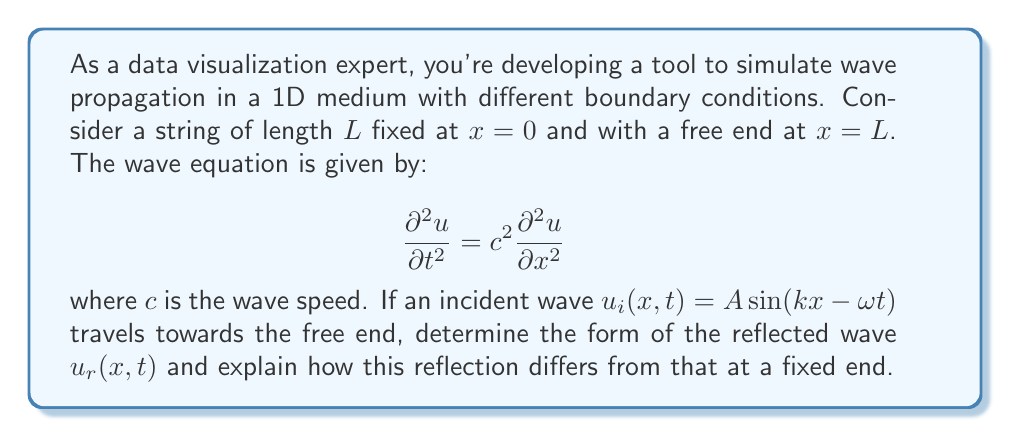Help me with this question. Let's approach this step-by-step:

1) First, recall the boundary conditions:
   - Fixed end at $x=0$: $u(0,t) = 0$
   - Free end at $x=L$: $\frac{\partial u}{\partial x}(L,t) = 0$

2) The incident wave is given by $u_i(x,t) = A \sin(kx - \omega t)$

3) For a free end, the reflected wave will have the same amplitude and phase as the incident wave. This is because the free end allows maximum displacement, resulting in constructive interference.

4) The reflected wave will be traveling in the opposite direction, so we change the sign of $kx$:
   $u_r(x,t) = A \sin(-kx - \omega t)$

5) Using the trigonometric identity $\sin(-\alpha) = -\sin(\alpha)$, we can rewrite this as:
   $u_r(x,t) = -A \sin(kx + \omega t)$

6) The total wave is the sum of incident and reflected waves:
   $u(x,t) = u_i(x,t) + u_r(x,t) = A \sin(kx - \omega t) - A \sin(kx + \omega t)$

7) Using the trigonometric identity for the difference of sines, this simplifies to:
   $u(x,t) = -2A \cos(kx) \sin(\omega t)$

8) This result shows a standing wave pattern, with nodes at positions where $\cos(kx) = 0$

9) Contrast this with reflection from a fixed end, where the reflected wave would be:
   $u_r(x,t) = -A \sin(kx + \omega t)$
   resulting in a total wave of $u(x,t) = 2A \sin(kx) \cos(\omega t)$

The key difference is the phase shift: reflection from a free end results in no phase change, while reflection from a fixed end results in a 180° phase change.
Answer: $u_r(x,t) = A \sin(-kx - \omega t) = -A \sin(kx + \omega t)$ 